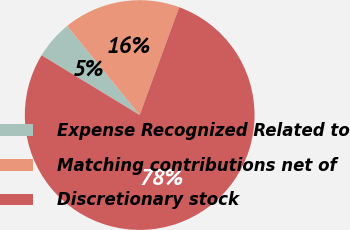Convert chart. <chart><loc_0><loc_0><loc_500><loc_500><pie_chart><fcel>Expense Recognized Related to<fcel>Matching contributions net of<fcel>Discretionary stock<nl><fcel>5.41%<fcel>16.47%<fcel>78.12%<nl></chart> 